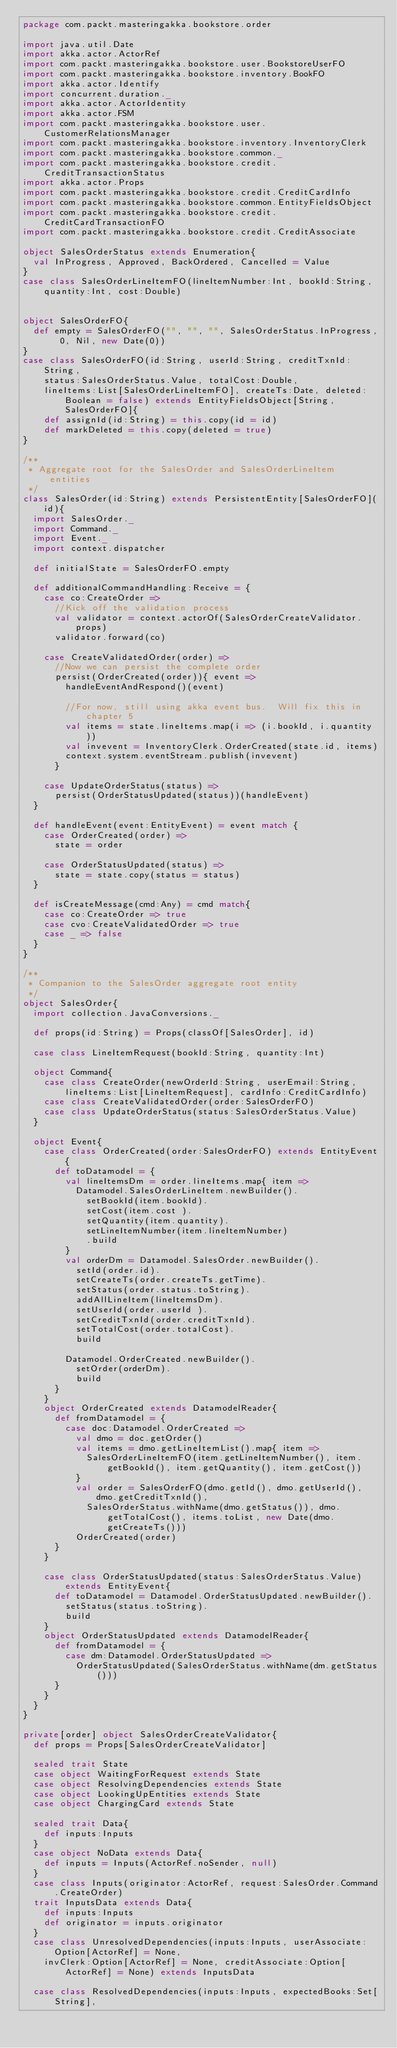Convert code to text. <code><loc_0><loc_0><loc_500><loc_500><_Scala_>package com.packt.masteringakka.bookstore.order

import java.util.Date
import akka.actor.ActorRef
import com.packt.masteringakka.bookstore.user.BookstoreUserFO
import com.packt.masteringakka.bookstore.inventory.BookFO
import akka.actor.Identify
import concurrent.duration._
import akka.actor.ActorIdentity
import akka.actor.FSM
import com.packt.masteringakka.bookstore.user.CustomerRelationsManager
import com.packt.masteringakka.bookstore.inventory.InventoryClerk
import com.packt.masteringakka.bookstore.common._
import com.packt.masteringakka.bookstore.credit.CreditTransactionStatus
import akka.actor.Props
import com.packt.masteringakka.bookstore.credit.CreditCardInfo
import com.packt.masteringakka.bookstore.common.EntityFieldsObject
import com.packt.masteringakka.bookstore.credit.CreditCardTransactionFO
import com.packt.masteringakka.bookstore.credit.CreditAssociate

object SalesOrderStatus extends Enumeration{
  val InProgress, Approved, BackOrdered, Cancelled = Value
}
case class SalesOrderLineItemFO(lineItemNumber:Int, bookId:String, quantity:Int, cost:Double)


object SalesOrderFO{
  def empty = SalesOrderFO("", "", "", SalesOrderStatus.InProgress, 0, Nil, new Date(0))
}
case class SalesOrderFO(id:String, userId:String, creditTxnId:String, 
    status:SalesOrderStatus.Value, totalCost:Double, 
    lineItems:List[SalesOrderLineItemFO], createTs:Date, deleted:Boolean = false) extends EntityFieldsObject[String, SalesOrderFO]{
    def assignId(id:String) = this.copy(id = id)
    def markDeleted = this.copy(deleted = true)
}

/**
 * Aggregate root for the SalesOrder and SalesOrderLineItem entities
 */
class SalesOrder(id:String) extends PersistentEntity[SalesOrderFO](id){
  import SalesOrder._
  import Command._
  import Event._
  import context.dispatcher
  
  def initialState = SalesOrderFO.empty
  
  def additionalCommandHandling:Receive = {
    case co:CreateOrder =>
      //Kick off the validation process
      val validator = context.actorOf(SalesOrderCreateValidator.props)
      validator.forward(co)
      
    case CreateValidatedOrder(order) =>
      //Now we can persist the complete order
      persist(OrderCreated(order)){ event =>        
        handleEventAndRespond()(event)
        
        //For now, still using akka event bus.  Will fix this in chapter 5
        val items = state.lineItems.map(i => (i.bookId, i.quantity ))
        val invevent = InventoryClerk.OrderCreated(state.id, items)
        context.system.eventStream.publish(invevent)        
      }
      
    case UpdateOrderStatus(status) =>
      persist(OrderStatusUpdated(status))(handleEvent)
  }
  
  def handleEvent(event:EntityEvent) = event match {
    case OrderCreated(order) =>
      state = order
      
    case OrderStatusUpdated(status) =>
      state = state.copy(status = status)
  }
  
  def isCreateMessage(cmd:Any) = cmd match{
    case co:CreateOrder => true
    case cvo:CreateValidatedOrder => true
    case _ => false
  }  
}

/**
 * Companion to the SalesOrder aggregate root entity
 */
object SalesOrder{
  import collection.JavaConversions._
  
  def props(id:String) = Props(classOf[SalesOrder], id)
  
  case class LineItemRequest(bookId:String, quantity:Int)
  
  object Command{
    case class CreateOrder(newOrderId:String, userEmail:String, lineItems:List[LineItemRequest], cardInfo:CreditCardInfo) 
    case class CreateValidatedOrder(order:SalesOrderFO)
    case class UpdateOrderStatus(status:SalesOrderStatus.Value)    
  }

  object Event{
    case class OrderCreated(order:SalesOrderFO) extends EntityEvent{
      def toDatamodel = {
        val lineItemsDm = order.lineItems.map{ item =>
          Datamodel.SalesOrderLineItem.newBuilder().
            setBookId(item.bookId).
            setCost(item.cost ).
            setQuantity(item.quantity).
            setLineItemNumber(item.lineItemNumber)
            .build
        }
        val orderDm = Datamodel.SalesOrder.newBuilder().
          setId(order.id).
          setCreateTs(order.createTs.getTime).
          setStatus(order.status.toString).
          addAllLineItem(lineItemsDm).
          setUserId(order.userId ).
          setCreditTxnId(order.creditTxnId).
          setTotalCost(order.totalCost).
          build
        
        Datamodel.OrderCreated.newBuilder().
          setOrder(orderDm).
          build
      }
    }
    object OrderCreated extends DatamodelReader{
      def fromDatamodel = {
        case doc:Datamodel.OrderCreated =>
          val dmo = doc.getOrder()
          val items = dmo.getLineItemList().map{ item =>
            SalesOrderLineItemFO(item.getLineItemNumber(), item.getBookId(), item.getQuantity(), item.getCost())
          }
          val order = SalesOrderFO(dmo.getId(), dmo.getUserId(), dmo.getCreditTxnId(),
            SalesOrderStatus.withName(dmo.getStatus()), dmo.getTotalCost(), items.toList, new Date(dmo.getCreateTs()))
          OrderCreated(order)
      }
    }
    
    case class OrderStatusUpdated(status:SalesOrderStatus.Value) extends EntityEvent{
      def toDatamodel = Datamodel.OrderStatusUpdated.newBuilder().
        setStatus(status.toString).
        build
    }    
    object OrderStatusUpdated extends DatamodelReader{
      def fromDatamodel = {
        case dm:Datamodel.OrderStatusUpdated =>
          OrderStatusUpdated(SalesOrderStatus.withName(dm.getStatus()))
      }
    }
  }
}

private[order] object SalesOrderCreateValidator{
  def props = Props[SalesOrderCreateValidator]
  
  sealed trait State
  case object WaitingForRequest extends State
  case object ResolvingDependencies extends State
  case object LookingUpEntities extends State
  case object ChargingCard extends State  
  
  sealed trait Data{
    def inputs:Inputs
  }
  case object NoData extends Data{
    def inputs = Inputs(ActorRef.noSender, null)
  }
  case class Inputs(originator:ActorRef, request:SalesOrder.Command.CreateOrder)
  trait InputsData extends Data{
    def inputs:Inputs
    def originator = inputs.originator 
  }  
  case class UnresolvedDependencies(inputs:Inputs, userAssociate:Option[ActorRef] = None, 
    invClerk:Option[ActorRef] = None, creditAssociate:Option[ActorRef] = None) extends InputsData

  case class ResolvedDependencies(inputs:Inputs, expectedBooks:Set[String], </code> 